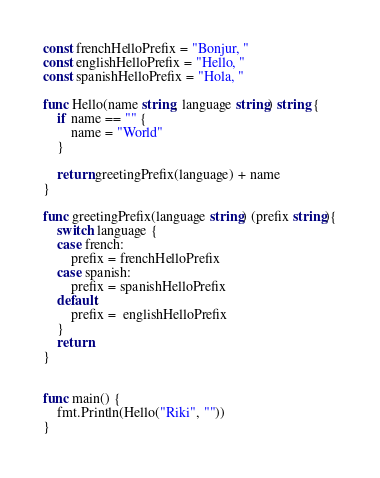Convert code to text. <code><loc_0><loc_0><loc_500><loc_500><_Go_>const frenchHelloPrefix = "Bonjur, "
const englishHelloPrefix = "Hello, "
const spanishHelloPrefix = "Hola, "

func Hello(name string, language string) string {
	if name == "" {
		name = "World"
	}

	return greetingPrefix(language) + name
}

func greetingPrefix(language string) (prefix string){
	switch language {
	case french:
		prefix = frenchHelloPrefix
	case spanish:
		prefix = spanishHelloPrefix
	default:
		prefix =  englishHelloPrefix
	}
	return
}


func main() {
	fmt.Println(Hello("Riki", ""))
}</code> 